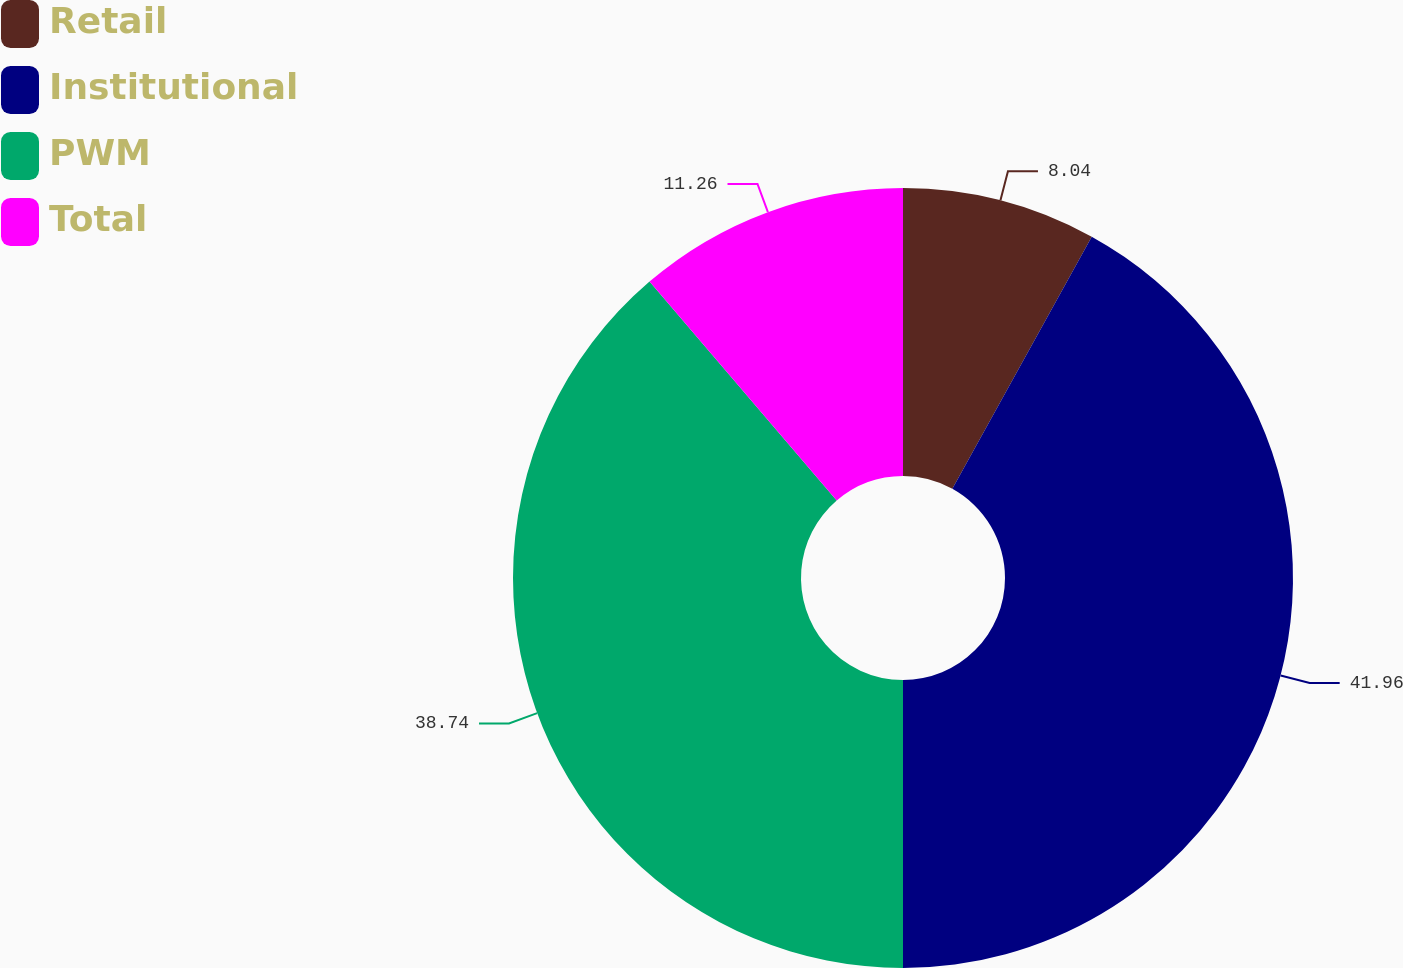<chart> <loc_0><loc_0><loc_500><loc_500><pie_chart><fcel>Retail<fcel>Institutional<fcel>PWM<fcel>Total<nl><fcel>8.04%<fcel>41.96%<fcel>38.74%<fcel>11.26%<nl></chart> 